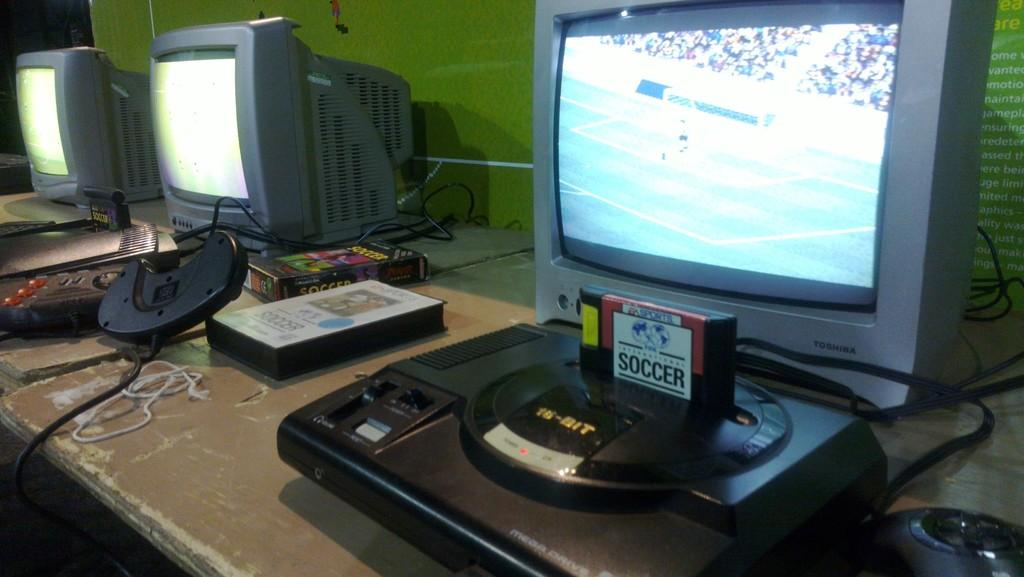What objects are on the tables in the image? There are monitors on tables in the image. What can be seen on the wall in the background of the image? There is a green color wall in the background of the image. What type of milk is being poured from a container in the image? There is no milk or container present in the image. What is the purpose of the alarm in the image? There is no alarm present in the image. 